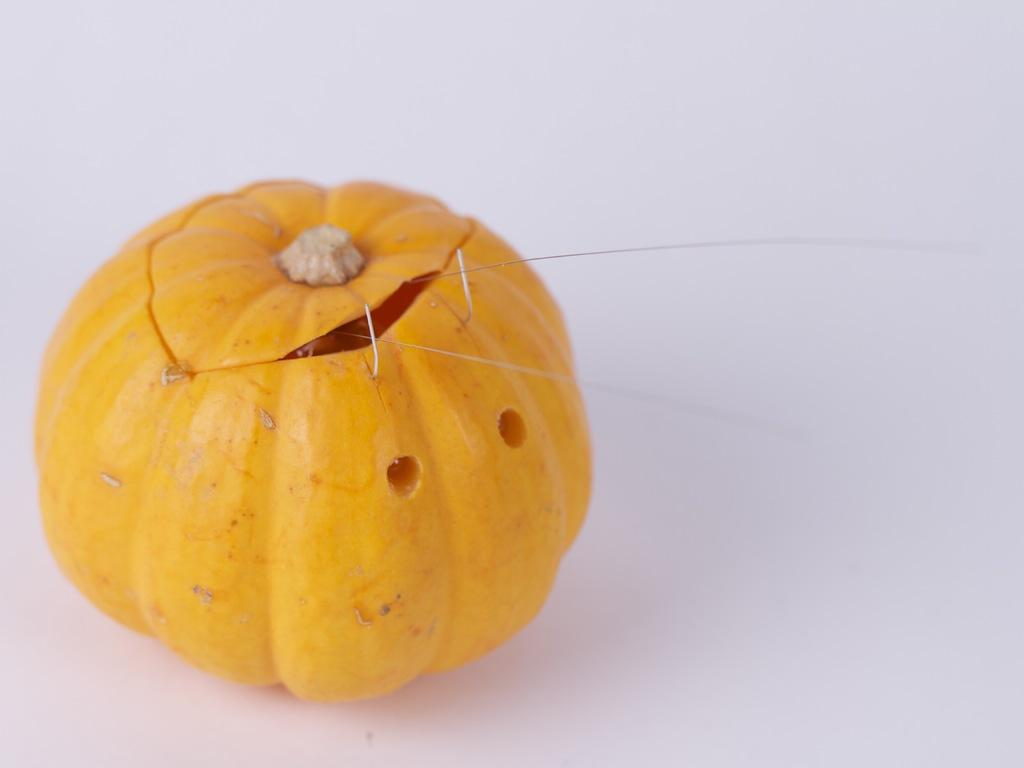What is the main object in the image? There is a pumpkin in the image. Where is the pumpkin located in the image? The pumpkin is on the left side of the image. What type of writing can be seen on the pumpkin in the image? There is no writing present on the pumpkin in the image. 